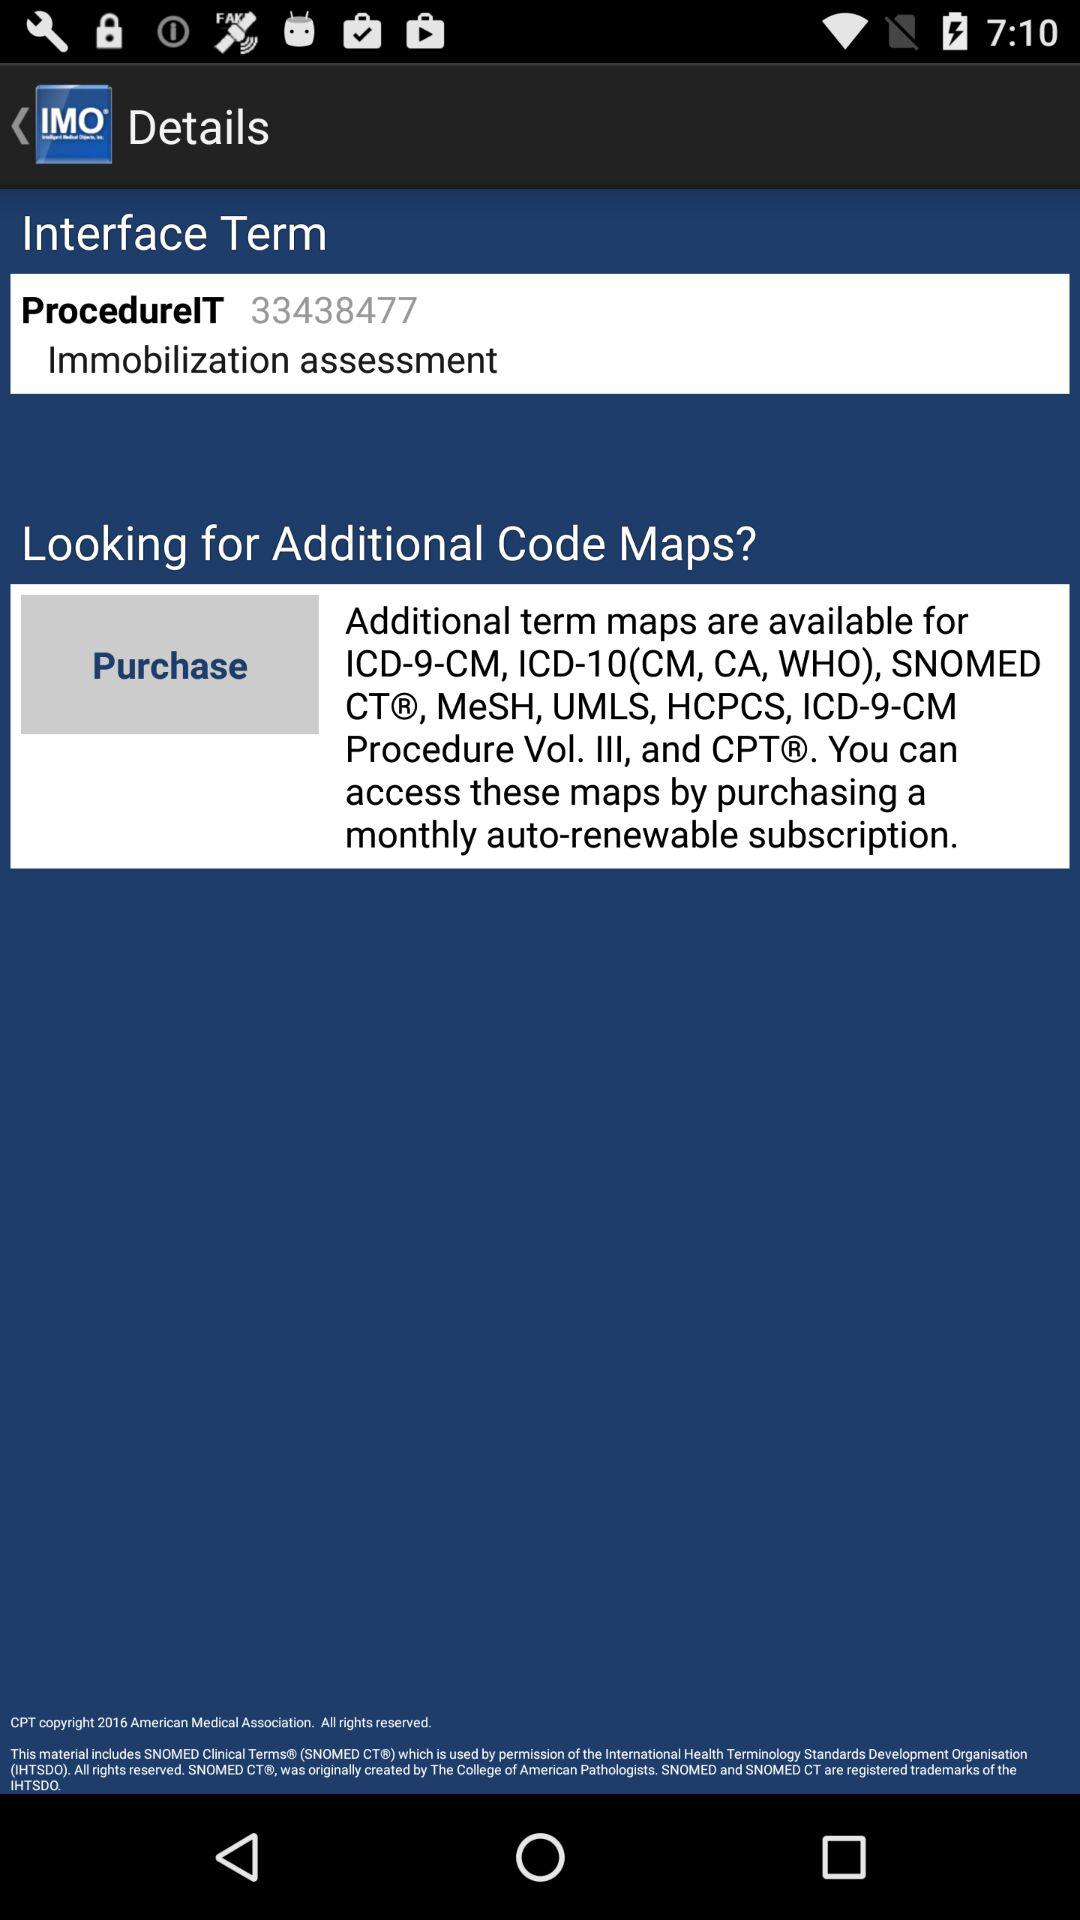What is the app title?
When the provided information is insufficient, respond with <no answer>. <no answer> 